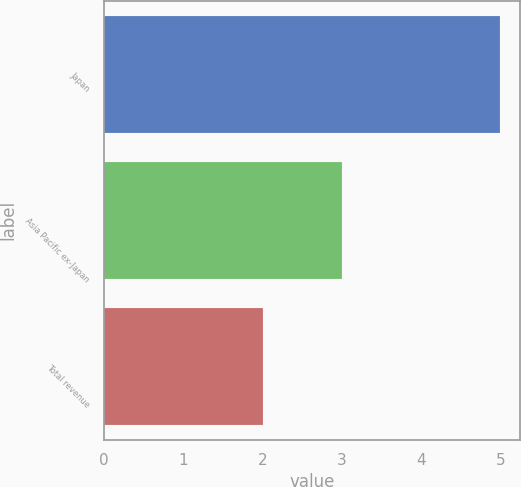<chart> <loc_0><loc_0><loc_500><loc_500><bar_chart><fcel>Japan<fcel>Asia Pacific ex-Japan<fcel>Total revenue<nl><fcel>5<fcel>3<fcel>2<nl></chart> 